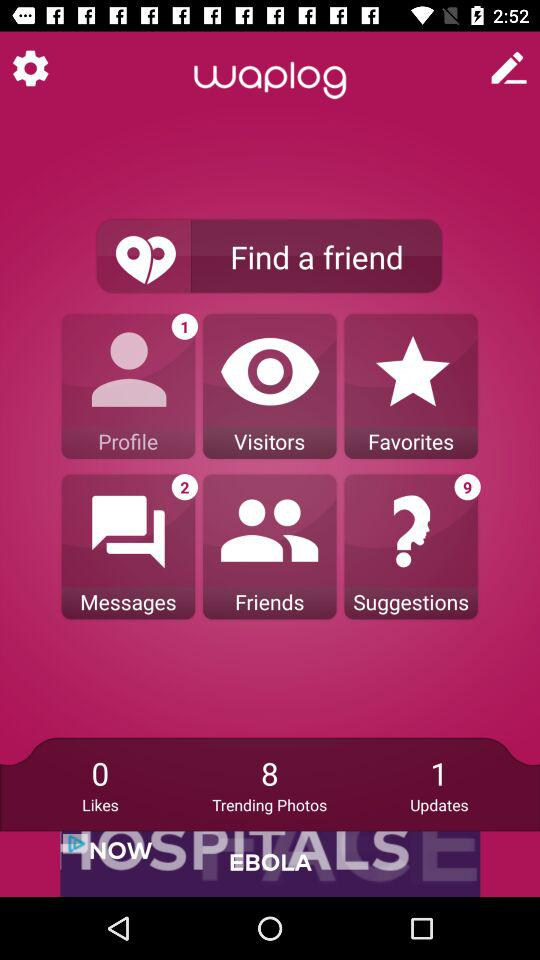Is there any update? There is 1 update. 